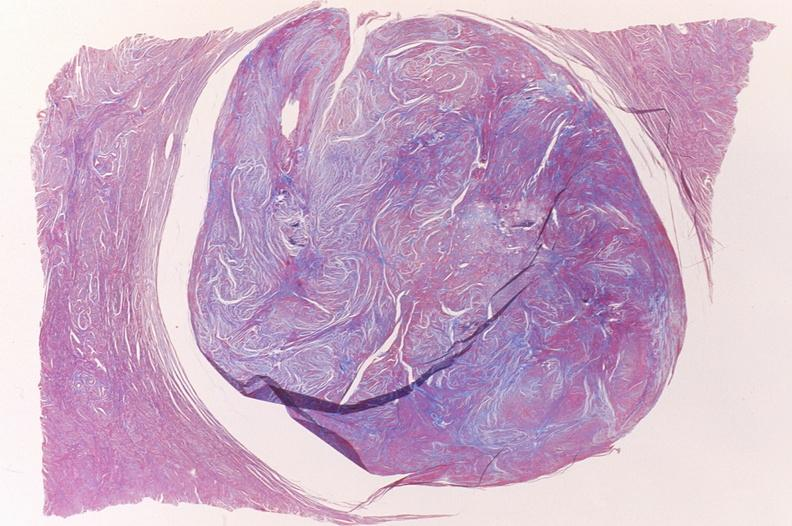s cranial artery present?
Answer the question using a single word or phrase. No 